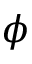<formula> <loc_0><loc_0><loc_500><loc_500>\phi</formula> 